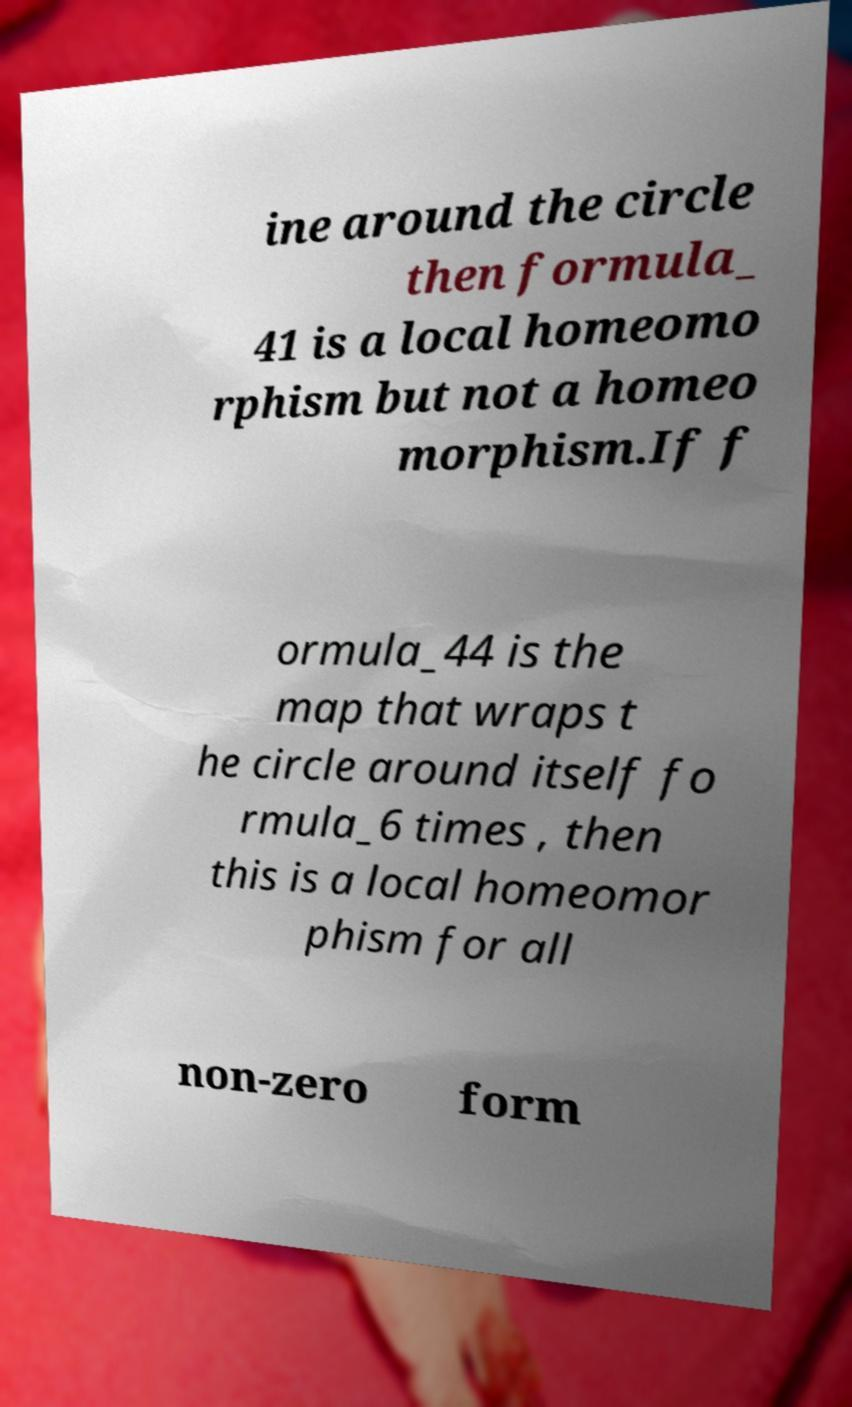Please identify and transcribe the text found in this image. ine around the circle then formula_ 41 is a local homeomo rphism but not a homeo morphism.If f ormula_44 is the map that wraps t he circle around itself fo rmula_6 times , then this is a local homeomor phism for all non-zero form 